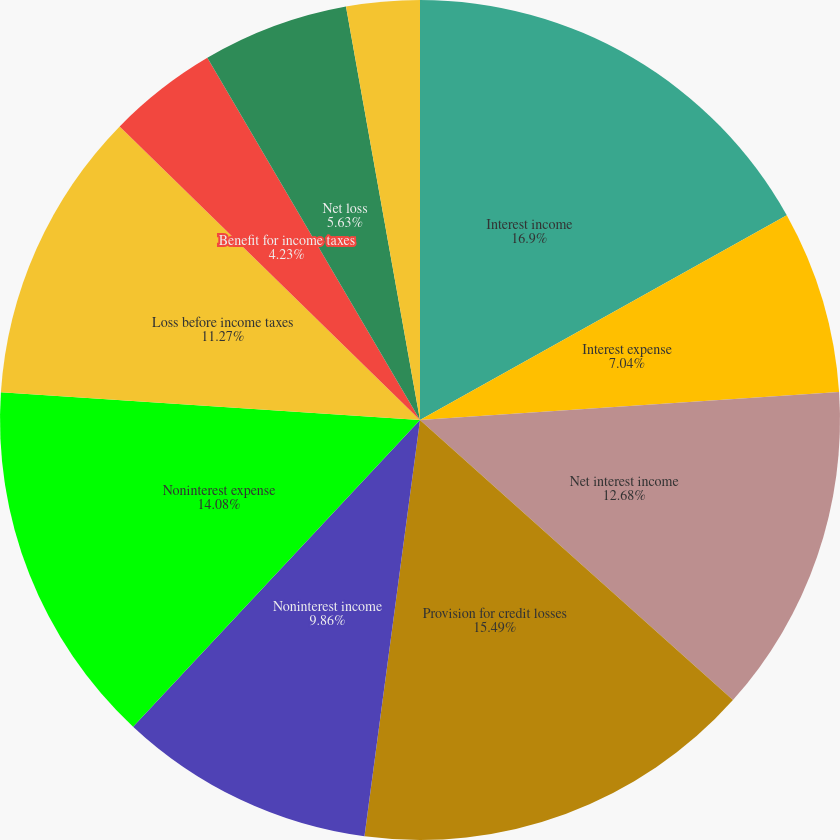<chart> <loc_0><loc_0><loc_500><loc_500><pie_chart><fcel>Interest income<fcel>Interest expense<fcel>Net interest income<fcel>Provision for credit losses<fcel>Noninterest income<fcel>Noninterest expense<fcel>Loss before income taxes<fcel>Benefit for income taxes<fcel>Net loss<fcel>Dividends declared on<nl><fcel>16.9%<fcel>7.04%<fcel>12.68%<fcel>15.49%<fcel>9.86%<fcel>14.08%<fcel>11.27%<fcel>4.23%<fcel>5.63%<fcel>2.82%<nl></chart> 